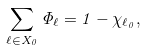<formula> <loc_0><loc_0><loc_500><loc_500>\sum _ { \ell \in X _ { 0 } } \Phi _ { \ell } = 1 - \chi _ { \ell _ { 0 } } ,</formula> 